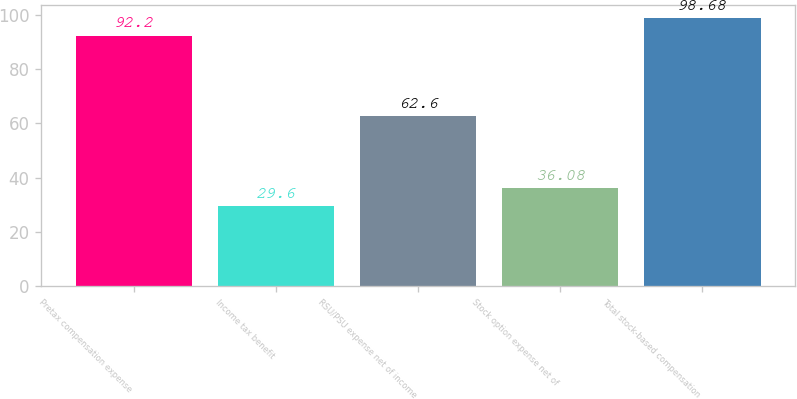<chart> <loc_0><loc_0><loc_500><loc_500><bar_chart><fcel>Pretax compensation expense<fcel>Income tax benefit<fcel>RSU/PSU expense net of income<fcel>Stock option expense net of<fcel>Total stock-based compensation<nl><fcel>92.2<fcel>29.6<fcel>62.6<fcel>36.08<fcel>98.68<nl></chart> 